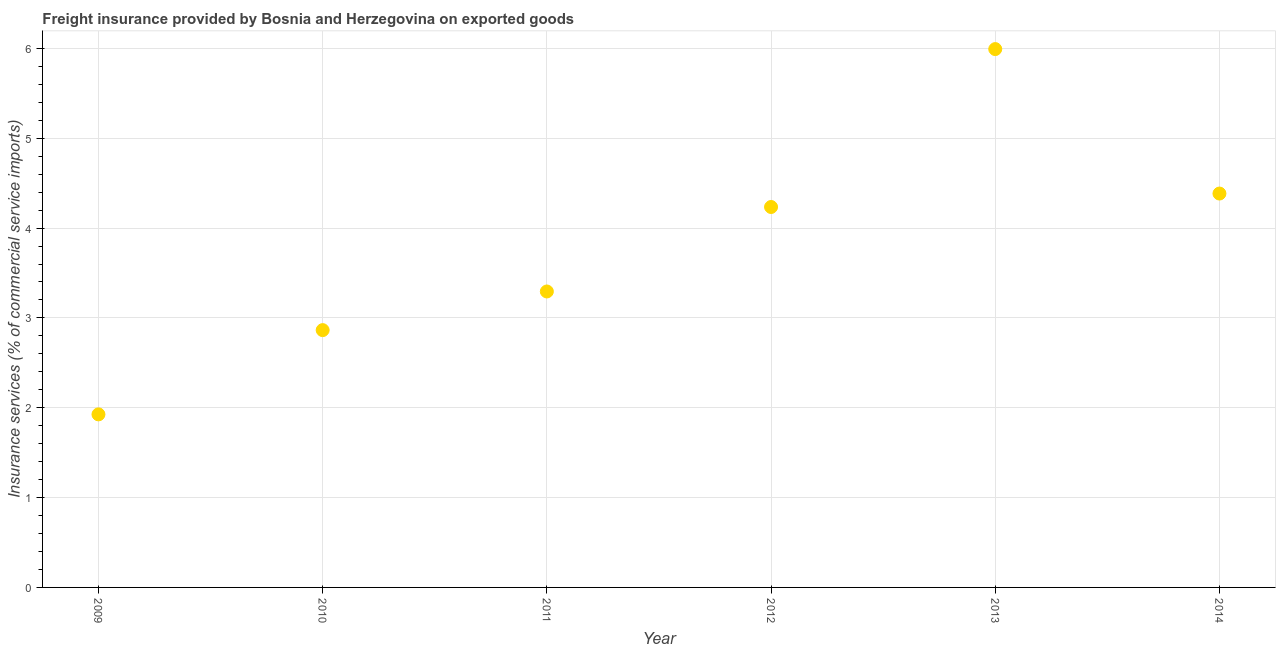What is the freight insurance in 2012?
Your answer should be very brief. 4.23. Across all years, what is the maximum freight insurance?
Give a very brief answer. 5.99. Across all years, what is the minimum freight insurance?
Ensure brevity in your answer.  1.93. In which year was the freight insurance maximum?
Your answer should be very brief. 2013. What is the sum of the freight insurance?
Keep it short and to the point. 22.7. What is the difference between the freight insurance in 2011 and 2013?
Ensure brevity in your answer.  -2.7. What is the average freight insurance per year?
Keep it short and to the point. 3.78. What is the median freight insurance?
Give a very brief answer. 3.76. What is the ratio of the freight insurance in 2009 to that in 2011?
Provide a succinct answer. 0.58. Is the freight insurance in 2010 less than that in 2013?
Offer a terse response. Yes. What is the difference between the highest and the second highest freight insurance?
Provide a succinct answer. 1.61. What is the difference between the highest and the lowest freight insurance?
Your answer should be very brief. 4.07. In how many years, is the freight insurance greater than the average freight insurance taken over all years?
Your response must be concise. 3. Does the freight insurance monotonically increase over the years?
Make the answer very short. No. How many dotlines are there?
Your answer should be compact. 1. How many years are there in the graph?
Give a very brief answer. 6. What is the difference between two consecutive major ticks on the Y-axis?
Provide a short and direct response. 1. Are the values on the major ticks of Y-axis written in scientific E-notation?
Make the answer very short. No. Does the graph contain any zero values?
Ensure brevity in your answer.  No. What is the title of the graph?
Ensure brevity in your answer.  Freight insurance provided by Bosnia and Herzegovina on exported goods . What is the label or title of the Y-axis?
Make the answer very short. Insurance services (% of commercial service imports). What is the Insurance services (% of commercial service imports) in 2009?
Your answer should be very brief. 1.93. What is the Insurance services (% of commercial service imports) in 2010?
Offer a very short reply. 2.86. What is the Insurance services (% of commercial service imports) in 2011?
Offer a very short reply. 3.29. What is the Insurance services (% of commercial service imports) in 2012?
Give a very brief answer. 4.23. What is the Insurance services (% of commercial service imports) in 2013?
Your answer should be very brief. 5.99. What is the Insurance services (% of commercial service imports) in 2014?
Ensure brevity in your answer.  4.38. What is the difference between the Insurance services (% of commercial service imports) in 2009 and 2010?
Give a very brief answer. -0.94. What is the difference between the Insurance services (% of commercial service imports) in 2009 and 2011?
Offer a very short reply. -1.37. What is the difference between the Insurance services (% of commercial service imports) in 2009 and 2012?
Offer a very short reply. -2.31. What is the difference between the Insurance services (% of commercial service imports) in 2009 and 2013?
Offer a terse response. -4.07. What is the difference between the Insurance services (% of commercial service imports) in 2009 and 2014?
Keep it short and to the point. -2.46. What is the difference between the Insurance services (% of commercial service imports) in 2010 and 2011?
Give a very brief answer. -0.43. What is the difference between the Insurance services (% of commercial service imports) in 2010 and 2012?
Your answer should be very brief. -1.37. What is the difference between the Insurance services (% of commercial service imports) in 2010 and 2013?
Your answer should be very brief. -3.13. What is the difference between the Insurance services (% of commercial service imports) in 2010 and 2014?
Offer a very short reply. -1.52. What is the difference between the Insurance services (% of commercial service imports) in 2011 and 2012?
Your response must be concise. -0.94. What is the difference between the Insurance services (% of commercial service imports) in 2011 and 2013?
Offer a very short reply. -2.7. What is the difference between the Insurance services (% of commercial service imports) in 2011 and 2014?
Offer a terse response. -1.09. What is the difference between the Insurance services (% of commercial service imports) in 2012 and 2013?
Your answer should be compact. -1.76. What is the difference between the Insurance services (% of commercial service imports) in 2012 and 2014?
Offer a very short reply. -0.15. What is the difference between the Insurance services (% of commercial service imports) in 2013 and 2014?
Give a very brief answer. 1.61. What is the ratio of the Insurance services (% of commercial service imports) in 2009 to that in 2010?
Your answer should be compact. 0.67. What is the ratio of the Insurance services (% of commercial service imports) in 2009 to that in 2011?
Offer a terse response. 0.58. What is the ratio of the Insurance services (% of commercial service imports) in 2009 to that in 2012?
Offer a very short reply. 0.46. What is the ratio of the Insurance services (% of commercial service imports) in 2009 to that in 2013?
Your answer should be compact. 0.32. What is the ratio of the Insurance services (% of commercial service imports) in 2009 to that in 2014?
Provide a succinct answer. 0.44. What is the ratio of the Insurance services (% of commercial service imports) in 2010 to that in 2011?
Give a very brief answer. 0.87. What is the ratio of the Insurance services (% of commercial service imports) in 2010 to that in 2012?
Keep it short and to the point. 0.68. What is the ratio of the Insurance services (% of commercial service imports) in 2010 to that in 2013?
Your response must be concise. 0.48. What is the ratio of the Insurance services (% of commercial service imports) in 2010 to that in 2014?
Provide a short and direct response. 0.65. What is the ratio of the Insurance services (% of commercial service imports) in 2011 to that in 2012?
Offer a terse response. 0.78. What is the ratio of the Insurance services (% of commercial service imports) in 2011 to that in 2013?
Provide a succinct answer. 0.55. What is the ratio of the Insurance services (% of commercial service imports) in 2011 to that in 2014?
Your response must be concise. 0.75. What is the ratio of the Insurance services (% of commercial service imports) in 2012 to that in 2013?
Give a very brief answer. 0.71. What is the ratio of the Insurance services (% of commercial service imports) in 2013 to that in 2014?
Your answer should be compact. 1.37. 